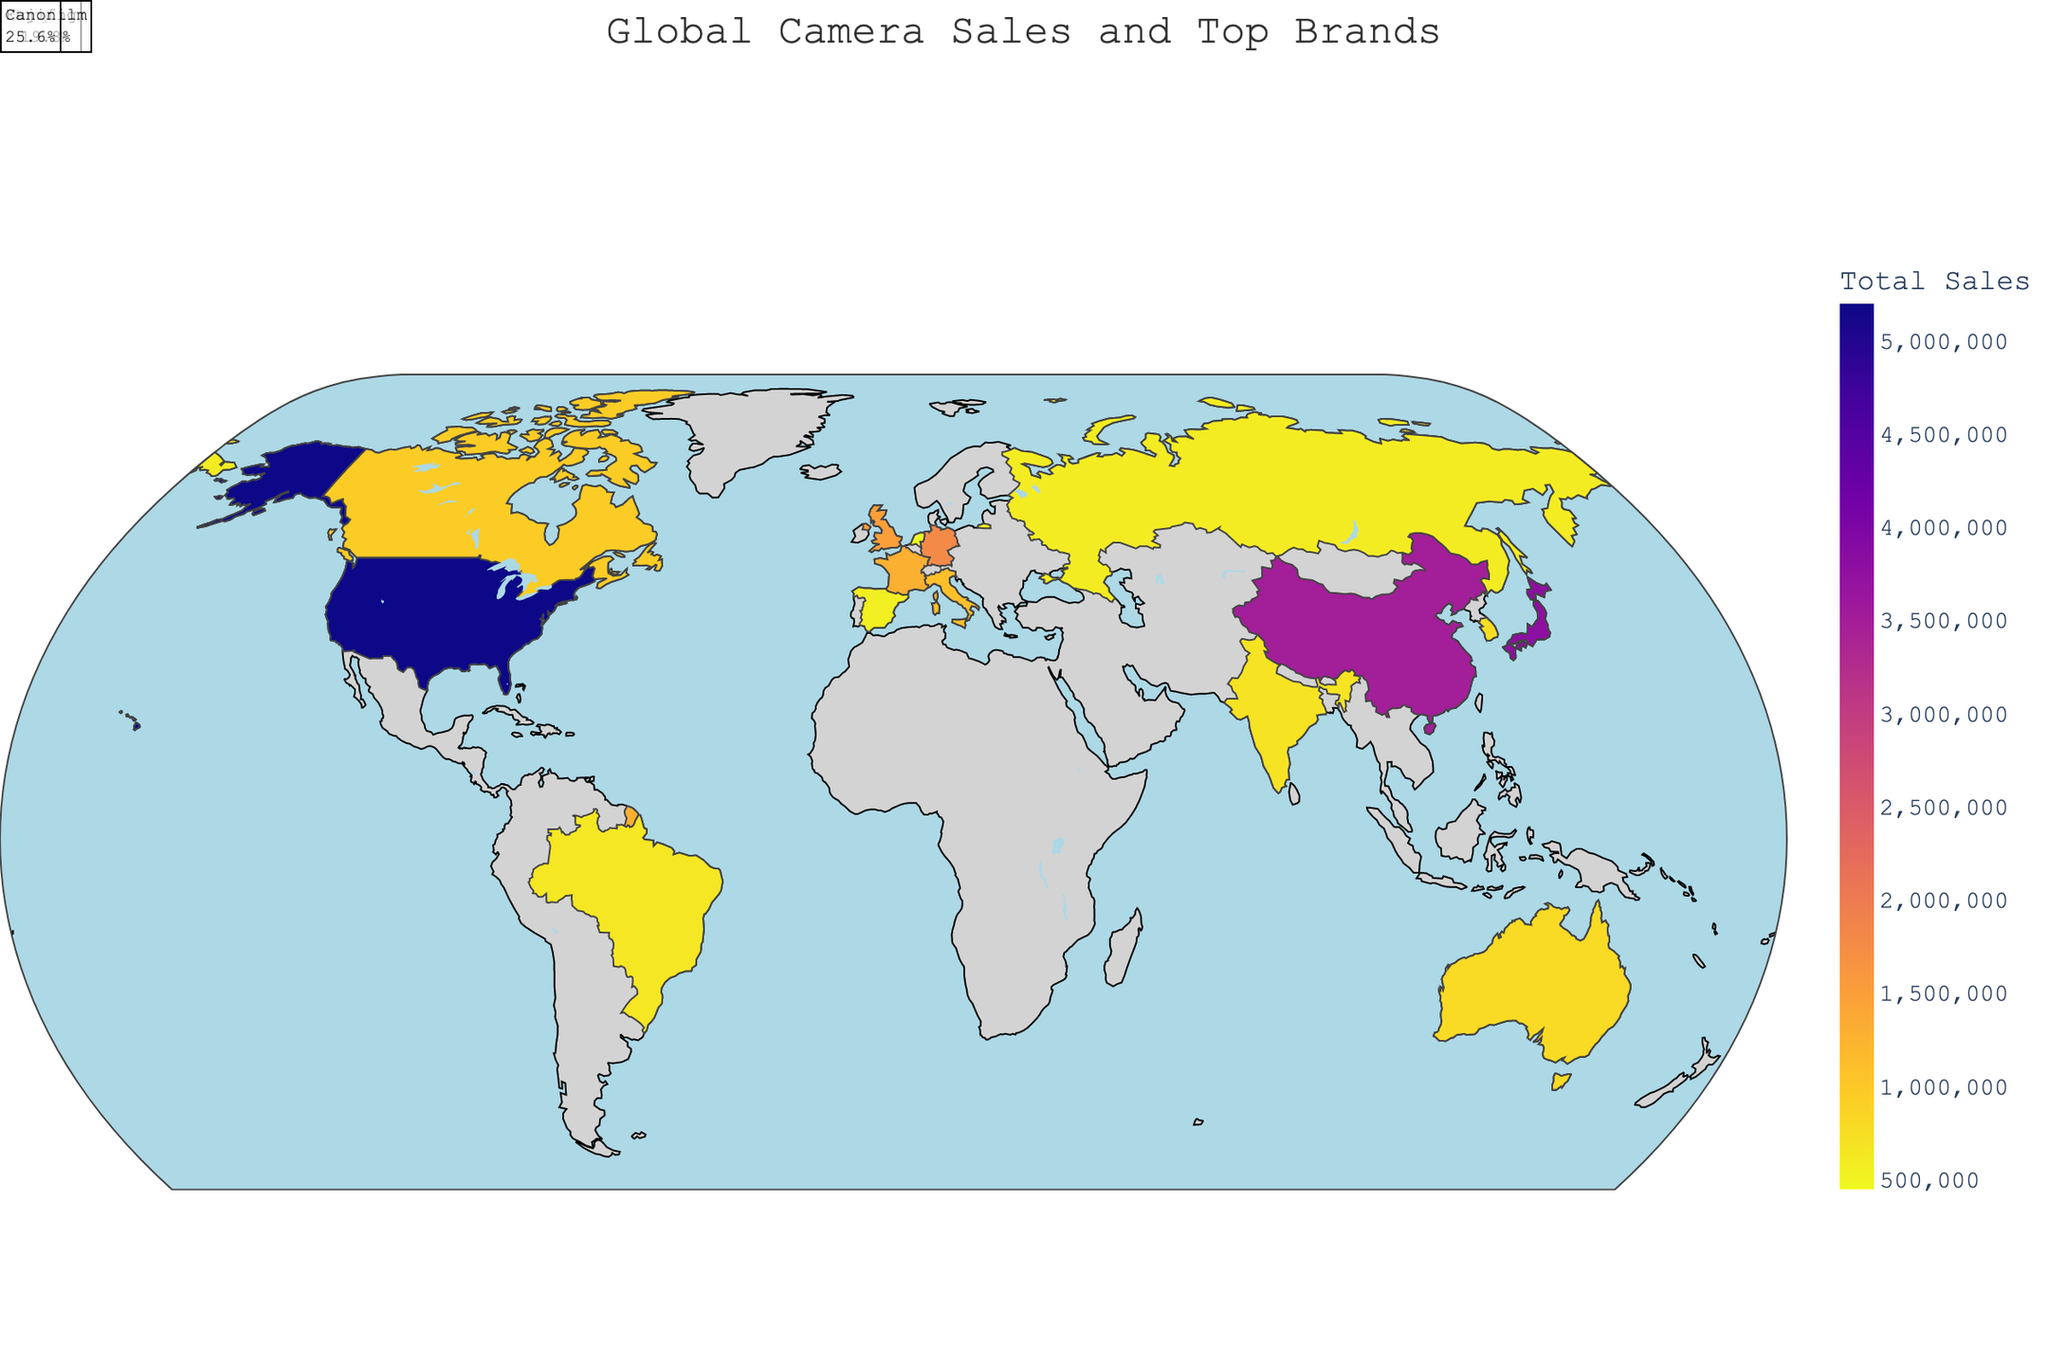What is the title of the figure? The title of the figure is usually located at the top center. By observing the visual, we can see the text indicating the title of the representation.
Answer: Global Camera Sales and Top Brands Which country has the highest total camera sales? The color gradient on the map indicates the intensity of sales, with the highest sales depicted in the most intense color. By referring to the brightest color on the map and the hover data, we can identify the country.
Answer: United States Which brand has the highest market share in South Korea? By hovering over or inspecting the annotation for South Korea, the information provided will show the top brand along with its market share.
Answer: Samsung How much greater are the total camera sales in the United States compared to Japan? First, identify the total sales for both countries from the visual data annotations and subtract the sales of Japan from the sales of the United States.
Answer: 1,400,000 What is the average market share of Canon across all the countries? Sum the market shares of Canon in each country where it is the top brand and then divide by the number of these countries. For Canon: (28.5 + 26.9 + 27.8 + 23.7 + 25.6) / 5.
Answer: 26.5 Which two countries have the closest total camera sales? Compare the sales data of all countries and identify the pair with the smallest difference in total sales. By inspecting the values, identify the closest pair.
Answer: Spain and Netherlands What is the most common top brand across all countries? By counting the instances of each top brand from the annotations, determine which brand appears the most.
Answer: Canon Which country in Europe has the lowest total camera sales? The European countries on the map can be identified and their sales can be compared to find the one with the lowest value.
Answer: Netherlands 